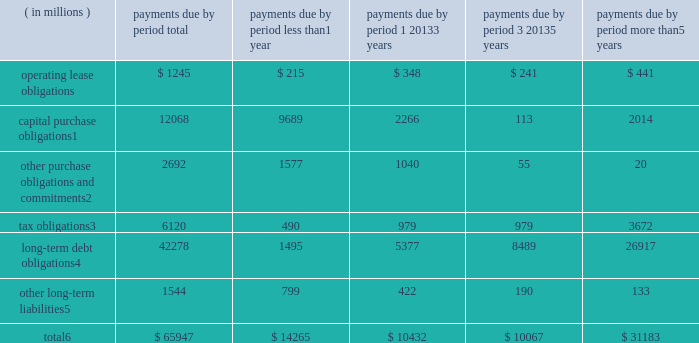Contractual obligations significant contractual obligations as of december 30 , 2017 were as follows: .
Capital purchase obligations1 12068 9689 2266 113 2014 other purchase obligations and commitments2 2692 1577 1040 55 20 tax obligations3 6120 490 979 979 3672 long-term debt obligations4 42278 1495 5377 8489 26917 other long-term liabilities5 1544 799 422 190 133 total6 $ 65947 $ 14265 $ 10432 $ 10067 $ 31183 1 capital purchase obligations represent commitments for the construction or purchase of property , plant and equipment .
They were not recorded as liabilities on our consolidated balance sheets as of december 30 , 2017 , as we had not yet received the related goods nor taken title to the property .
2 other purchase obligations and commitments include payments due under various types of licenses and agreements to purchase goods or services , as well as payments due under non-contingent funding obligations .
3 tax obligations represent the future cash payments related to tax reform enacted in 2017 for the one-time provisional transition tax on our previously untaxed foreign earnings .
For further information , see 201cnote 8 : income taxes 201d within the consolidated financial statements .
4 amounts represent principal and interest cash payments over the life of the debt obligations , including anticipated interest payments that are not recorded on our consolidated balance sheets .
Debt obligations are classified based on their stated maturity date , regardless of their classification on the consolidated balance sheets .
Any future settlement of convertible debt would impact our cash payments .
5 amounts represent future cash payments to satisfy other long-term liabilities recorded on our consolidated balance sheets , including the short-term portion of these long-term liabilities .
Derivative instruments are excluded from the preceding table , as they do not represent the amounts that may ultimately be paid .
6 total excludes contractual obligations already recorded on our consolidated balance sheets as current liabilities , except for the short-term portions of long-term debt obligations and other long-term liabilities .
The expected timing of payments of the obligations in the preceding table is estimated based on current information .
Timing of payments and actual amounts paid may be different , depending on the time of receipt of goods or services , or changes to agreed- upon amounts for some obligations .
Contractual obligations for purchases of goods or services included in 201cother purchase obligations and commitments 201d in the preceding table include agreements that are enforceable and legally binding on intel and that specify all significant terms , including fixed or minimum quantities to be purchased ; fixed , minimum , or variable price provisions ; and the approximate timing of the transaction .
For obligations with cancellation provisions , the amounts included in the preceding table were limited to the non-cancelable portion of the agreement terms or the minimum cancellation fee .
For the purchase of raw materials , we have entered into certain agreements that specify minimum prices and quantities based on a percentage of the total available market or based on a percentage of our future purchasing requirements .
Due to the uncertainty of the future market and our future purchasing requirements , as well as the non-binding nature of these agreements , obligations under these agreements have been excluded from the preceding table .
Our purchase orders for other products are based on our current manufacturing needs and are fulfilled by our vendors within short time horizons .
In addition , some of our purchase orders represent authorizations to purchase rather than binding agreements .
Contractual obligations that are contingent upon the achievement of certain milestones have been excluded from the preceding table .
Most of our milestone-based contracts are tooling related for the purchase of capital equipment .
These arrangements are not considered contractual obligations until the milestone is met by the counterparty .
As of december 30 , 2017 , assuming that all future milestones are met , the additional required payments would be approximately $ 2.0 billion .
For the majority of restricted stock units ( rsus ) granted , the number of shares of common stock issued on the date the rsus vest is net of the minimum statutory withholding requirements that we pay in cash to the appropriate taxing authorities on behalf of our employees .
The obligation to pay the relevant taxing authority is excluded from the preceding table , as the amount is contingent upon continued employment .
In addition , the amount of the obligation is unknown , as it is based in part on the market price of our common stock when the awards vest .
Md&a - results of operations consolidated results and analysis 38 .
What percentage of total contractual obligations do capital purchase obligations make up as of december 30 2017? 
Computations: (12068 / 65947)
Answer: 0.183. 